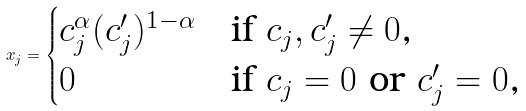Convert formula to latex. <formula><loc_0><loc_0><loc_500><loc_500>x _ { j } = \begin{cases} c _ { j } ^ { \alpha } ( c _ { j } ^ { \prime } ) ^ { 1 - \alpha } & \text {if $c_{j}, c_{j}^{\prime}\ne 0$,} \\ 0 & \text {if $c_{j}=0$ or $c_{j}^{\prime}= 0$,} \end{cases}</formula> 